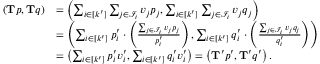Convert formula to latex. <formula><loc_0><loc_0><loc_500><loc_500>\begin{array} { r l } { ( T p , T q ) } & { = \left ( \sum _ { i \in [ k ^ { \prime } ] } \sum _ { j \in \mathcal { I } _ { i } } v _ { j } p _ { j } , \sum _ { i \in [ k ^ { \prime } ] } \sum _ { j \in \mathcal { I } _ { i } } v _ { j } q _ { j } \right ) } \\ & { = \left ( \sum _ { i \in [ k ^ { \prime } ] } p _ { i } ^ { \prime } \cdot \left ( \frac { \sum _ { j \in \mathcal { I } _ { i } } v _ { j } p _ { j } } { p _ { i } ^ { \prime } } \right ) , \sum _ { i \in [ k ^ { \prime } ] } q _ { i } ^ { \prime } \cdot \left ( \frac { \sum _ { j \in \mathcal { I } _ { i } } v _ { j } q _ { j } } { q _ { i } ^ { \prime } } \right ) \right ) } \\ & { = \left ( \sum _ { i \in [ k ^ { \prime } ] } p _ { i } ^ { \prime } v _ { i } ^ { \prime } , \sum _ { i \in [ k ^ { \prime } ] } q _ { i } ^ { \prime } v _ { i } ^ { \prime } \right ) = \left ( T ^ { \prime } p ^ { \prime } , T ^ { \prime } q ^ { \prime } \right ) . } \end{array}</formula> 